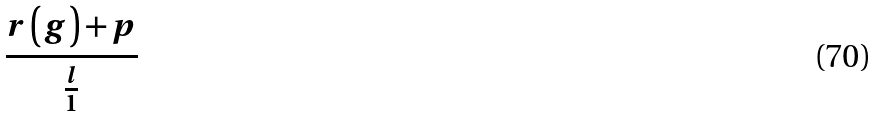<formula> <loc_0><loc_0><loc_500><loc_500>\frac { r \left ( g \right ) + p } { \frac { l } { 1 } }</formula> 